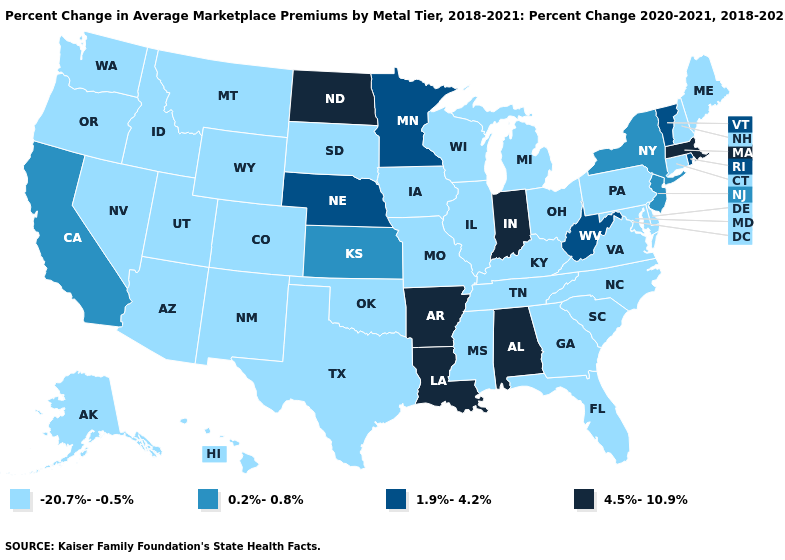Does Utah have the same value as Mississippi?
Short answer required. Yes. Name the states that have a value in the range 4.5%-10.9%?
Quick response, please. Alabama, Arkansas, Indiana, Louisiana, Massachusetts, North Dakota. Does Louisiana have the highest value in the USA?
Concise answer only. Yes. Does North Dakota have the highest value in the MidWest?
Answer briefly. Yes. What is the value of Wyoming?
Answer briefly. -20.7%--0.5%. What is the highest value in the South ?
Short answer required. 4.5%-10.9%. What is the value of Kentucky?
Keep it brief. -20.7%--0.5%. What is the lowest value in the USA?
Answer briefly. -20.7%--0.5%. What is the value of Indiana?
Concise answer only. 4.5%-10.9%. Name the states that have a value in the range 0.2%-0.8%?
Be succinct. California, Kansas, New Jersey, New York. Does California have the highest value in the West?
Write a very short answer. Yes. Name the states that have a value in the range 0.2%-0.8%?
Be succinct. California, Kansas, New Jersey, New York. What is the highest value in the USA?
Quick response, please. 4.5%-10.9%. Does Oklahoma have the highest value in the South?
Answer briefly. No. What is the value of Arkansas?
Quick response, please. 4.5%-10.9%. 